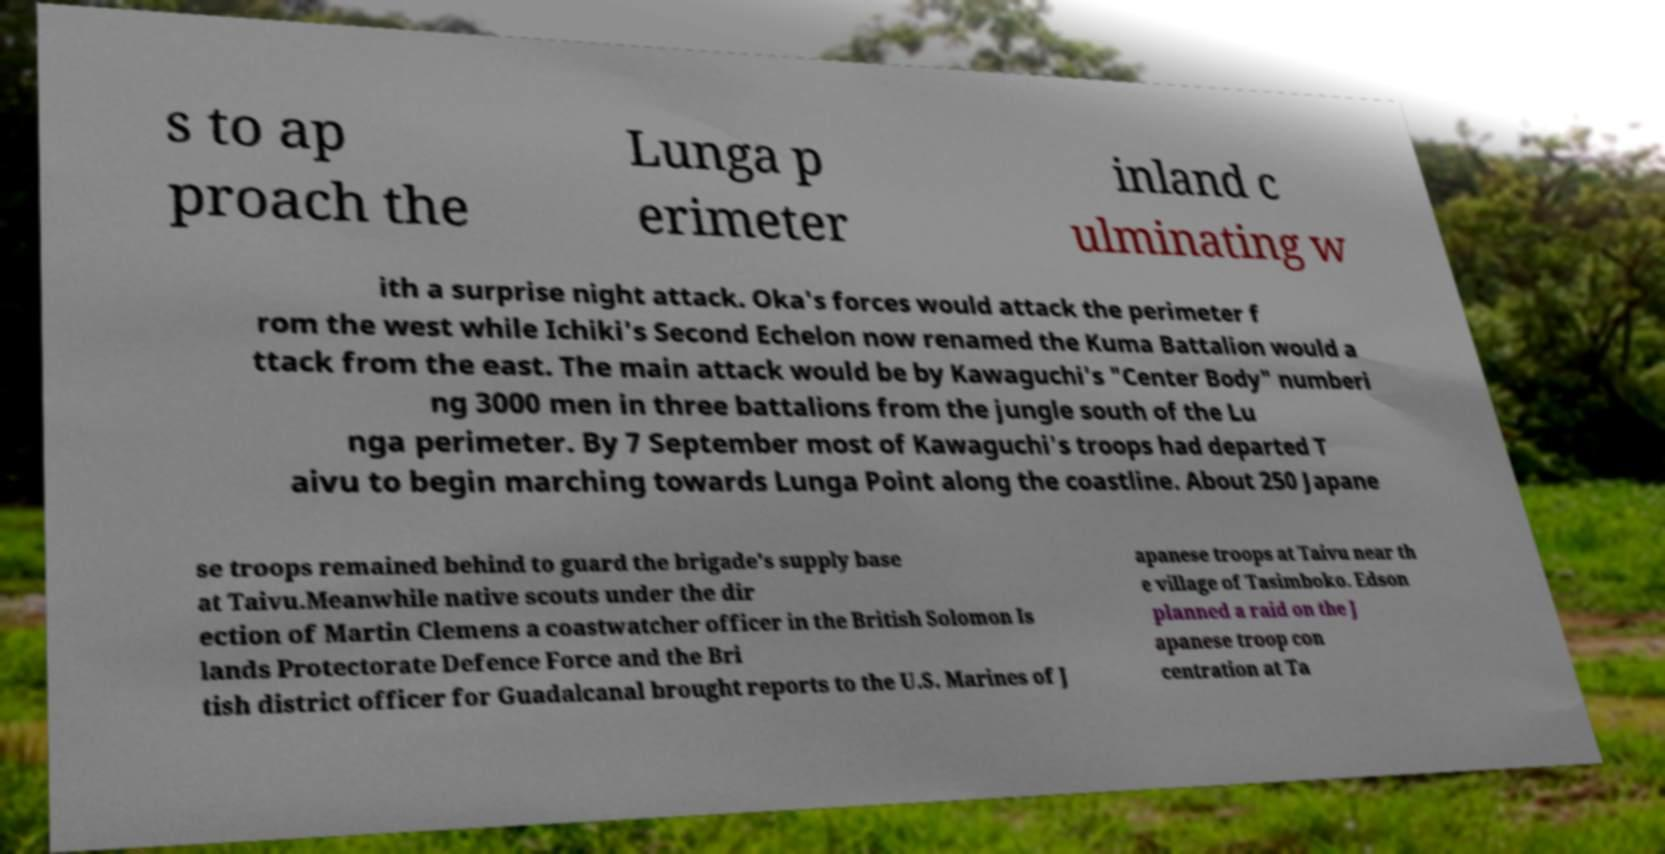There's text embedded in this image that I need extracted. Can you transcribe it verbatim? s to ap proach the Lunga p erimeter inland c ulminating w ith a surprise night attack. Oka's forces would attack the perimeter f rom the west while Ichiki's Second Echelon now renamed the Kuma Battalion would a ttack from the east. The main attack would be by Kawaguchi's "Center Body" numberi ng 3000 men in three battalions from the jungle south of the Lu nga perimeter. By 7 September most of Kawaguchi's troops had departed T aivu to begin marching towards Lunga Point along the coastline. About 250 Japane se troops remained behind to guard the brigade's supply base at Taivu.Meanwhile native scouts under the dir ection of Martin Clemens a coastwatcher officer in the British Solomon Is lands Protectorate Defence Force and the Bri tish district officer for Guadalcanal brought reports to the U.S. Marines of J apanese troops at Taivu near th e village of Tasimboko. Edson planned a raid on the J apanese troop con centration at Ta 